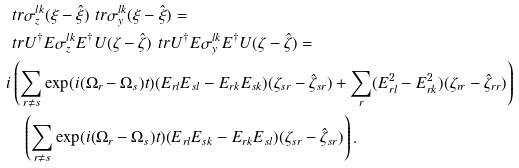Convert formula to latex. <formula><loc_0><loc_0><loc_500><loc_500>& \ t r { \sigma _ { z } ^ { l k } ( \xi - \hat { \xi } ) } \ t r { \sigma _ { y } ^ { l k } ( \xi - \hat { \xi } ) } = \\ & \ t r { U ^ { \dag } E \sigma _ { z } ^ { l k } E ^ { \dag } U ( \zeta - \hat { \zeta } ) } \ t r { U ^ { \dag } E \sigma _ { y } ^ { l k } E ^ { \dag } U ( \zeta - \hat { \zeta } ) } = \\ & i \left ( \sum _ { r \neq s } \exp ( i ( \Omega _ { r } - \Omega _ { s } ) t ) ( E _ { r l } E _ { s l } - E _ { r k } E _ { s k } ) ( \zeta _ { s r } - \hat { \zeta } _ { s r } ) + \sum _ { r } ( E _ { r l } ^ { 2 } - E _ { r k } ^ { 2 } ) ( \zeta _ { r r } - \hat { \zeta } _ { r r } ) \right ) \\ & \quad \left ( \sum _ { r \neq s } \exp ( i ( \Omega _ { r } - \Omega _ { s } ) t ) ( E _ { r l } E _ { s k } - E _ { r k } E _ { s l } ) ( \zeta _ { s r } - \hat { \zeta } _ { s r } ) \right ) .</formula> 